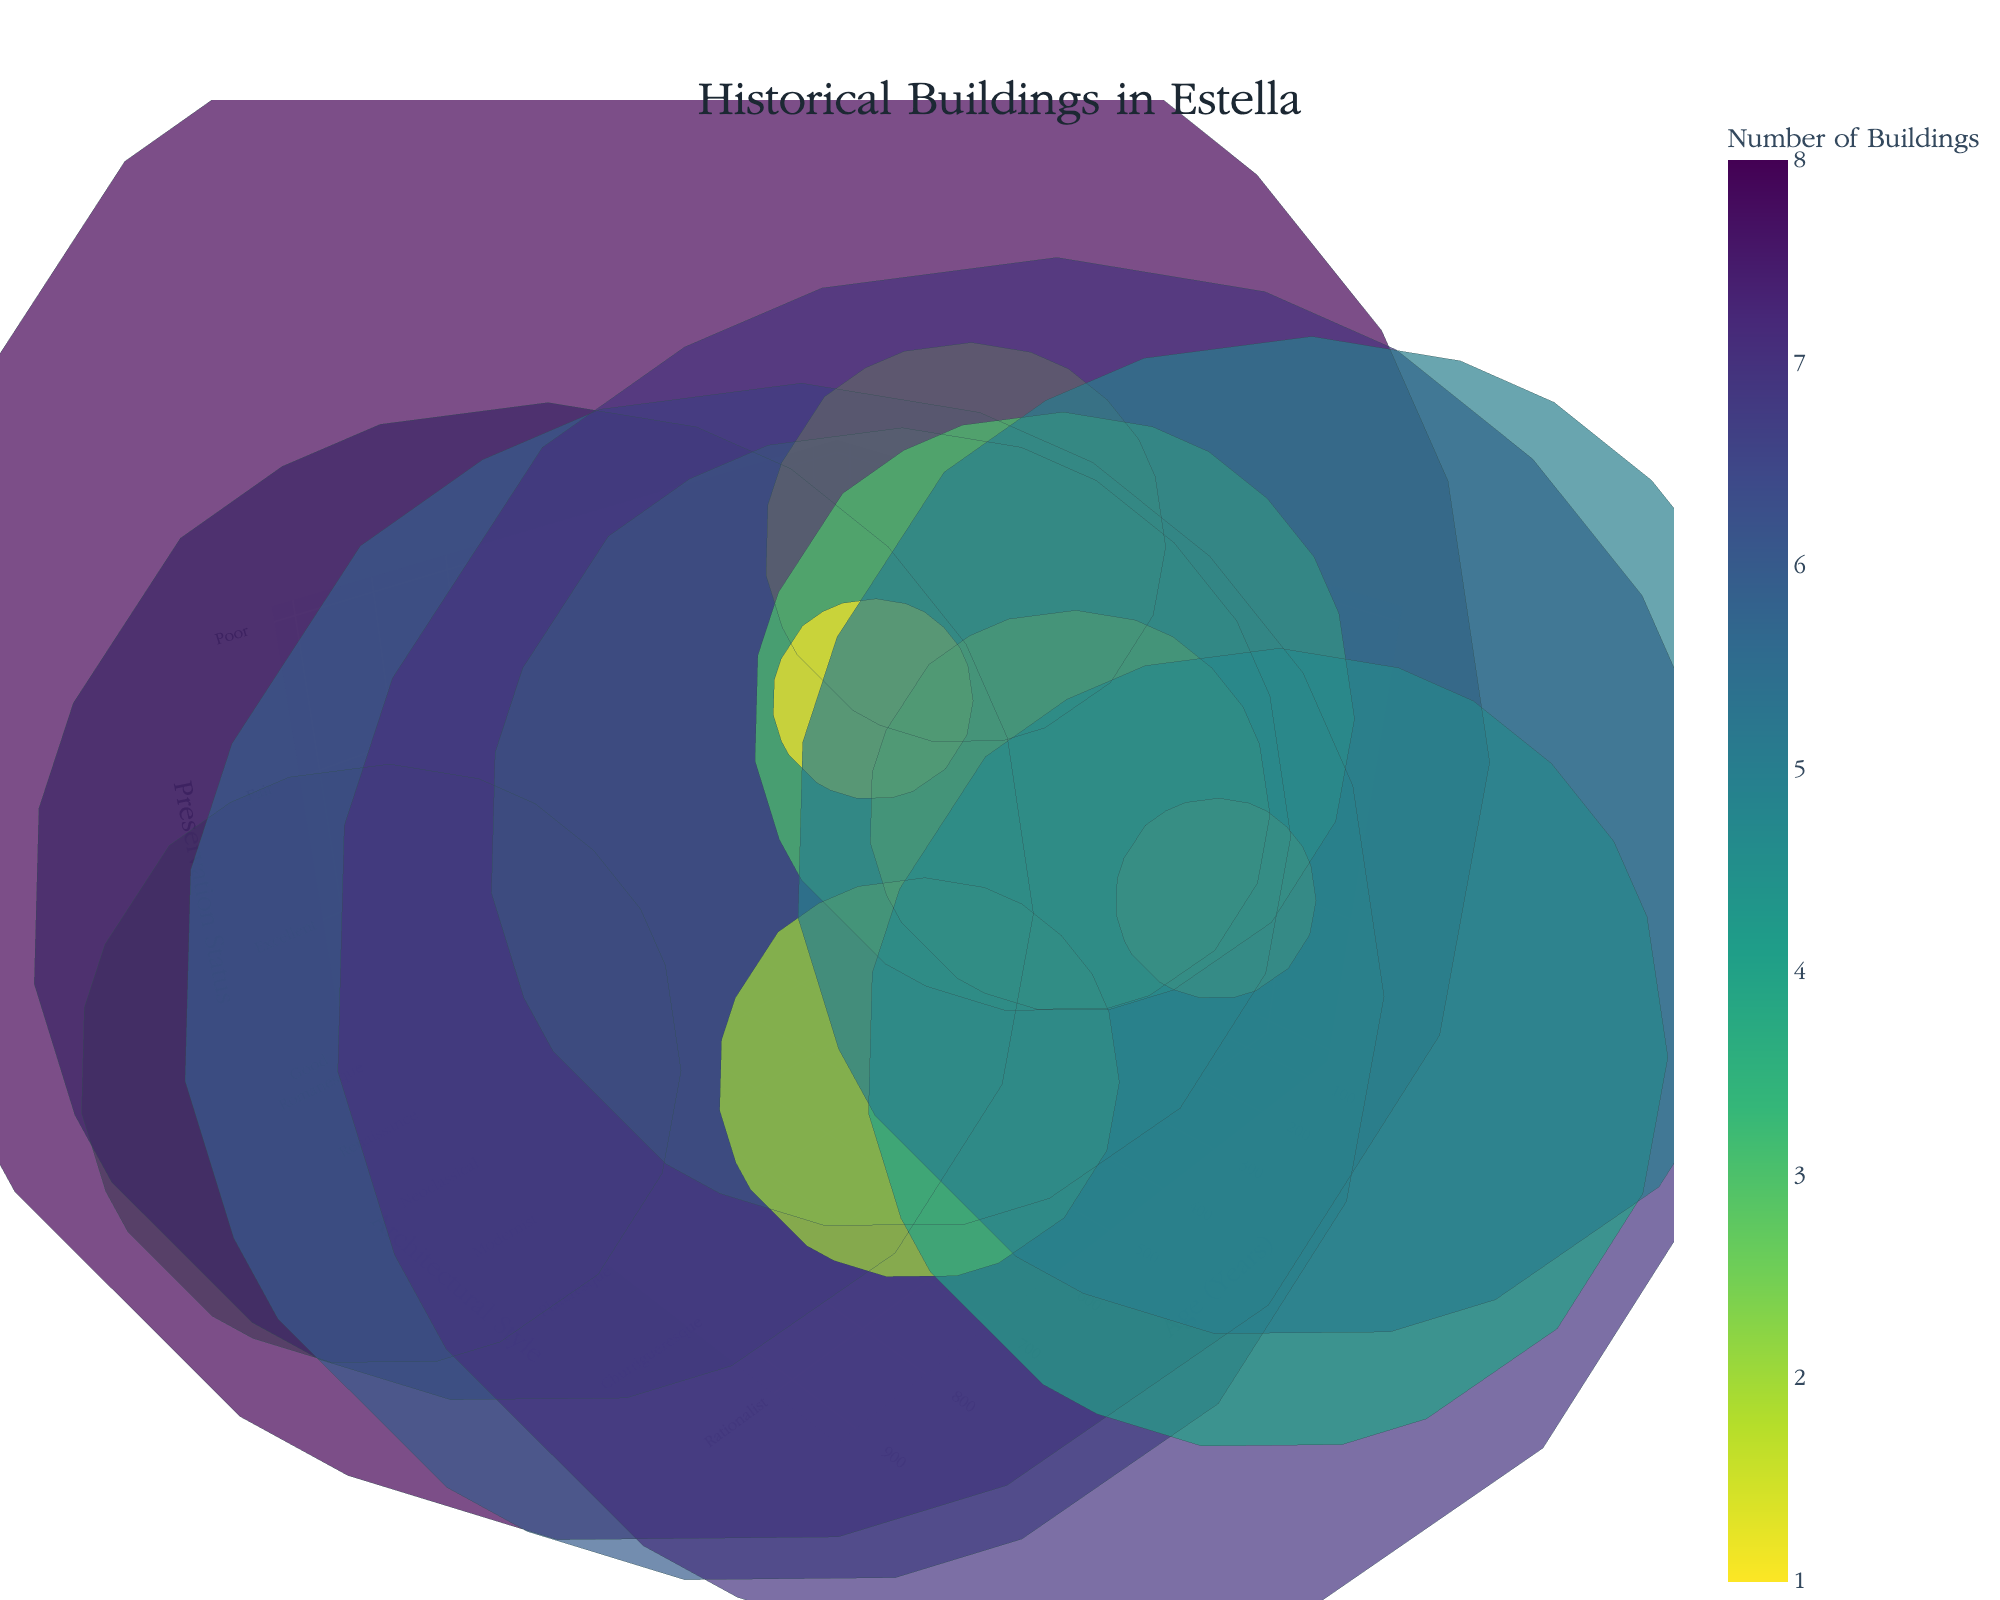What's the title of the figure? The title is displayed at the top of the figure in a larger font. It states the main topic or purpose of the visual representation.
Answer: Historical Buildings in Estella What are the axes labeled with? The axes labels are shown along each axis to explain what variables they represent. The x-axis is labeled 'Age (Years)', the y-axis is labeled 'Architectural Style', and the z-axis is labeled 'Preservation Status'.
Answer: Age (Years), Architectural Style, Preservation Status Which architectural style has the highest number of buildings? Hover over the bubbles or observe the bubble sizes to find the style with the largest bubble. The largest bubble represents the highest number of buildings.
Answer: Renaissance What is the preservation status of Gothic buildings? Locate the Gothic style along the y-axis and observe the corresponding z-axis value or hover over the bubble for its label.
Answer: Excellent Which architectural styles have buildings with 'Good' preservation status? Identify bubbles aligned with the 'Good' value along the z-axis or check the preservation status in pop-up details while hovering over bubbles.
Answer: Romanesque, Baroque, Modernist, Plateresque, Rationalist How many buildings are from the Modernist style and what is their preservation status? On the y-axis, find Modernist, then hover over the corresponding bubble to see the number of buildings and their preservation status.
Answer: 7 buildings, Good Which style has buildings older than 600 years? Look for bubbles positioned above 600 years on the x-axis and read their corresponding architectural styles.
Answer: Romanesque, Gothic How many Neo-Gothic buildings are there and their preservation status? Find the Neo-Gothic bubble on the y-axis and observe the size and hover details for the number of buildings and preservation status.
Answer: 3 buildings, Fair Compare the number of Gothic and Neoclassical buildings. Which has more and how many more? Locate bubbles for Gothic and Neoclassical along the y-axis, compare their sizes and hover to find precise numbers to calculate the difference. Gothic has 5 buildings and Neoclassical has 4, so 5 - 4 = 1.
Answer: Gothic, 1 more What is the age and number of buildings for the style with the poorest preservation status? Identify the bubbles with 'Poor' on the z-axis, examine their positions on the x-axis for age, and check the hover details for the number of buildings. Romanticist is 180 years and Mudejar is 600 years. Romanticist has 2 buildings and Mudejar has 1, the poorest preservation status is tied between these two.
Answer: Age: 180 and 600 years, Number: 2 and 1 buildings 